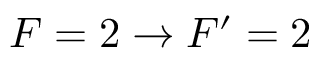<formula> <loc_0><loc_0><loc_500><loc_500>F = 2 \rightarrow F ^ { \prime } = 2</formula> 